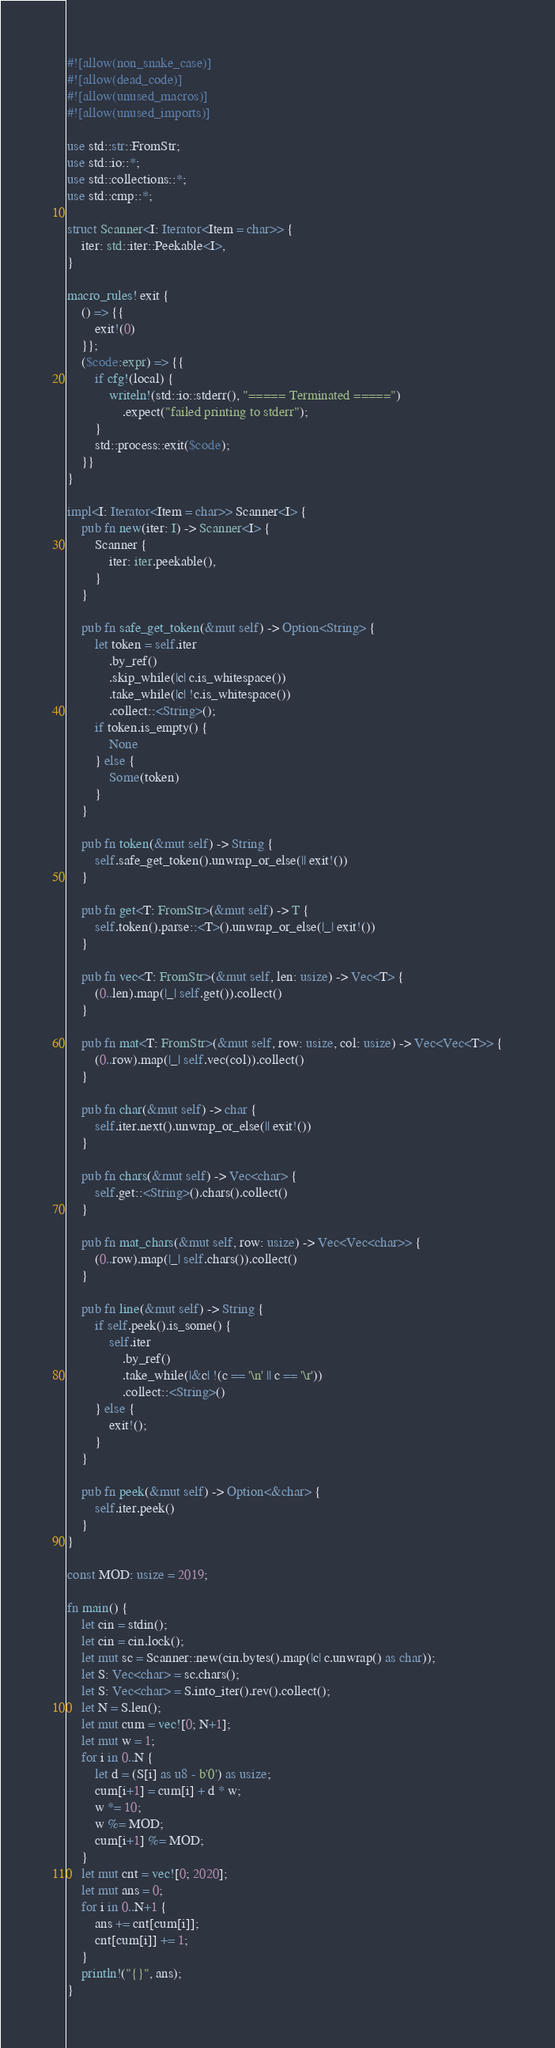Convert code to text. <code><loc_0><loc_0><loc_500><loc_500><_Rust_>#![allow(non_snake_case)]
#![allow(dead_code)]
#![allow(unused_macros)]
#![allow(unused_imports)]

use std::str::FromStr;
use std::io::*;
use std::collections::*;
use std::cmp::*;

struct Scanner<I: Iterator<Item = char>> {
    iter: std::iter::Peekable<I>,
}

macro_rules! exit {
    () => {{
        exit!(0)
    }};
    ($code:expr) => {{
        if cfg!(local) {
            writeln!(std::io::stderr(), "===== Terminated =====")
                .expect("failed printing to stderr");
        }
        std::process::exit($code);
    }}
}

impl<I: Iterator<Item = char>> Scanner<I> {
    pub fn new(iter: I) -> Scanner<I> {
        Scanner {
            iter: iter.peekable(),
        }
    }

    pub fn safe_get_token(&mut self) -> Option<String> {
        let token = self.iter
            .by_ref()
            .skip_while(|c| c.is_whitespace())
            .take_while(|c| !c.is_whitespace())
            .collect::<String>();
        if token.is_empty() {
            None
        } else {
            Some(token)
        }
    }

    pub fn token(&mut self) -> String {
        self.safe_get_token().unwrap_or_else(|| exit!())
    }

    pub fn get<T: FromStr>(&mut self) -> T {
        self.token().parse::<T>().unwrap_or_else(|_| exit!())
    }

    pub fn vec<T: FromStr>(&mut self, len: usize) -> Vec<T> {
        (0..len).map(|_| self.get()).collect()
    }

    pub fn mat<T: FromStr>(&mut self, row: usize, col: usize) -> Vec<Vec<T>> {
        (0..row).map(|_| self.vec(col)).collect()
    }

    pub fn char(&mut self) -> char {
        self.iter.next().unwrap_or_else(|| exit!())
    }

    pub fn chars(&mut self) -> Vec<char> {
        self.get::<String>().chars().collect()
    }

    pub fn mat_chars(&mut self, row: usize) -> Vec<Vec<char>> {
        (0..row).map(|_| self.chars()).collect()
    }

    pub fn line(&mut self) -> String {
        if self.peek().is_some() {
            self.iter
                .by_ref()
                .take_while(|&c| !(c == '\n' || c == '\r'))
                .collect::<String>()
        } else {
            exit!();
        }
    }

    pub fn peek(&mut self) -> Option<&char> {
        self.iter.peek()
    }
}

const MOD: usize = 2019;

fn main() {
    let cin = stdin();
    let cin = cin.lock();
    let mut sc = Scanner::new(cin.bytes().map(|c| c.unwrap() as char));
    let S: Vec<char> = sc.chars();
    let S: Vec<char> = S.into_iter().rev().collect();
    let N = S.len();
    let mut cum = vec![0; N+1];
    let mut w = 1;
    for i in 0..N {
        let d = (S[i] as u8 - b'0') as usize;
        cum[i+1] = cum[i] + d * w;
        w *= 10;
        w %= MOD;
        cum[i+1] %= MOD;
    }
    let mut cnt = vec![0; 2020];
    let mut ans = 0;
    for i in 0..N+1 {
        ans += cnt[cum[i]];
        cnt[cum[i]] += 1;
    }
    println!("{}", ans);
}
</code> 